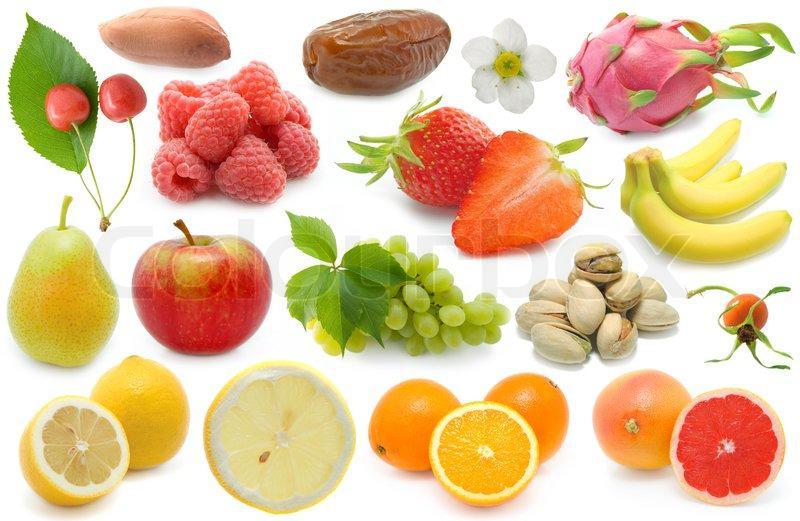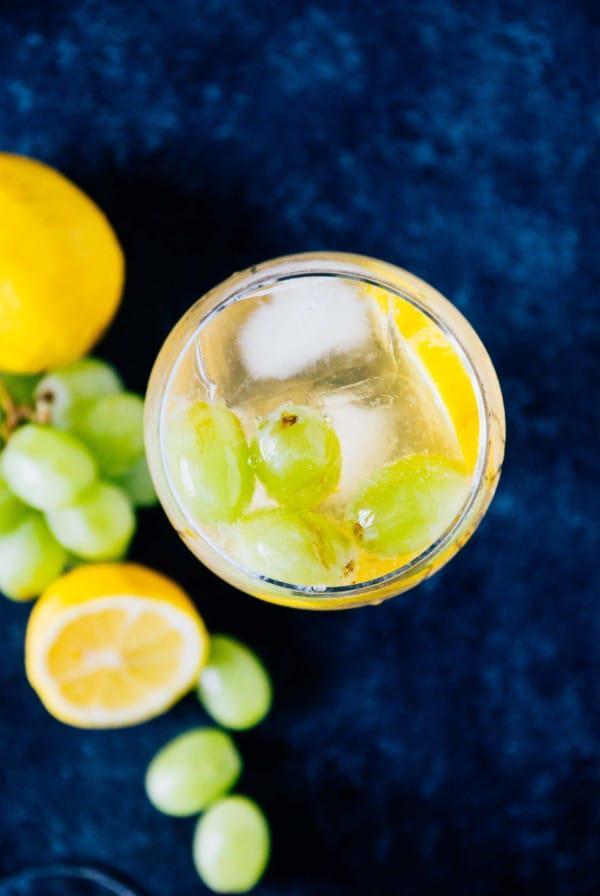The first image is the image on the left, the second image is the image on the right. Evaluate the accuracy of this statement regarding the images: "At least one image features a bunch of purple grapes on the vine.". Is it true? Answer yes or no. No. 